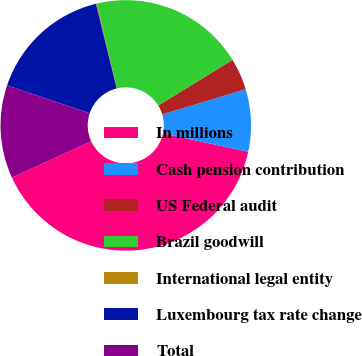<chart> <loc_0><loc_0><loc_500><loc_500><pie_chart><fcel>In millions<fcel>Cash pension contribution<fcel>US Federal audit<fcel>Brazil goodwill<fcel>International legal entity<fcel>Luxembourg tax rate change<fcel>Total<nl><fcel>39.79%<fcel>8.05%<fcel>4.09%<fcel>19.95%<fcel>0.12%<fcel>15.99%<fcel>12.02%<nl></chart> 